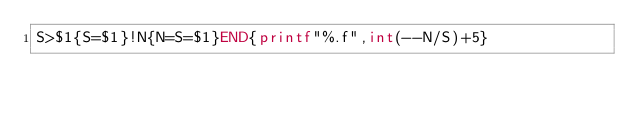Convert code to text. <code><loc_0><loc_0><loc_500><loc_500><_Awk_>S>$1{S=$1}!N{N=S=$1}END{printf"%.f",int(--N/S)+5}</code> 